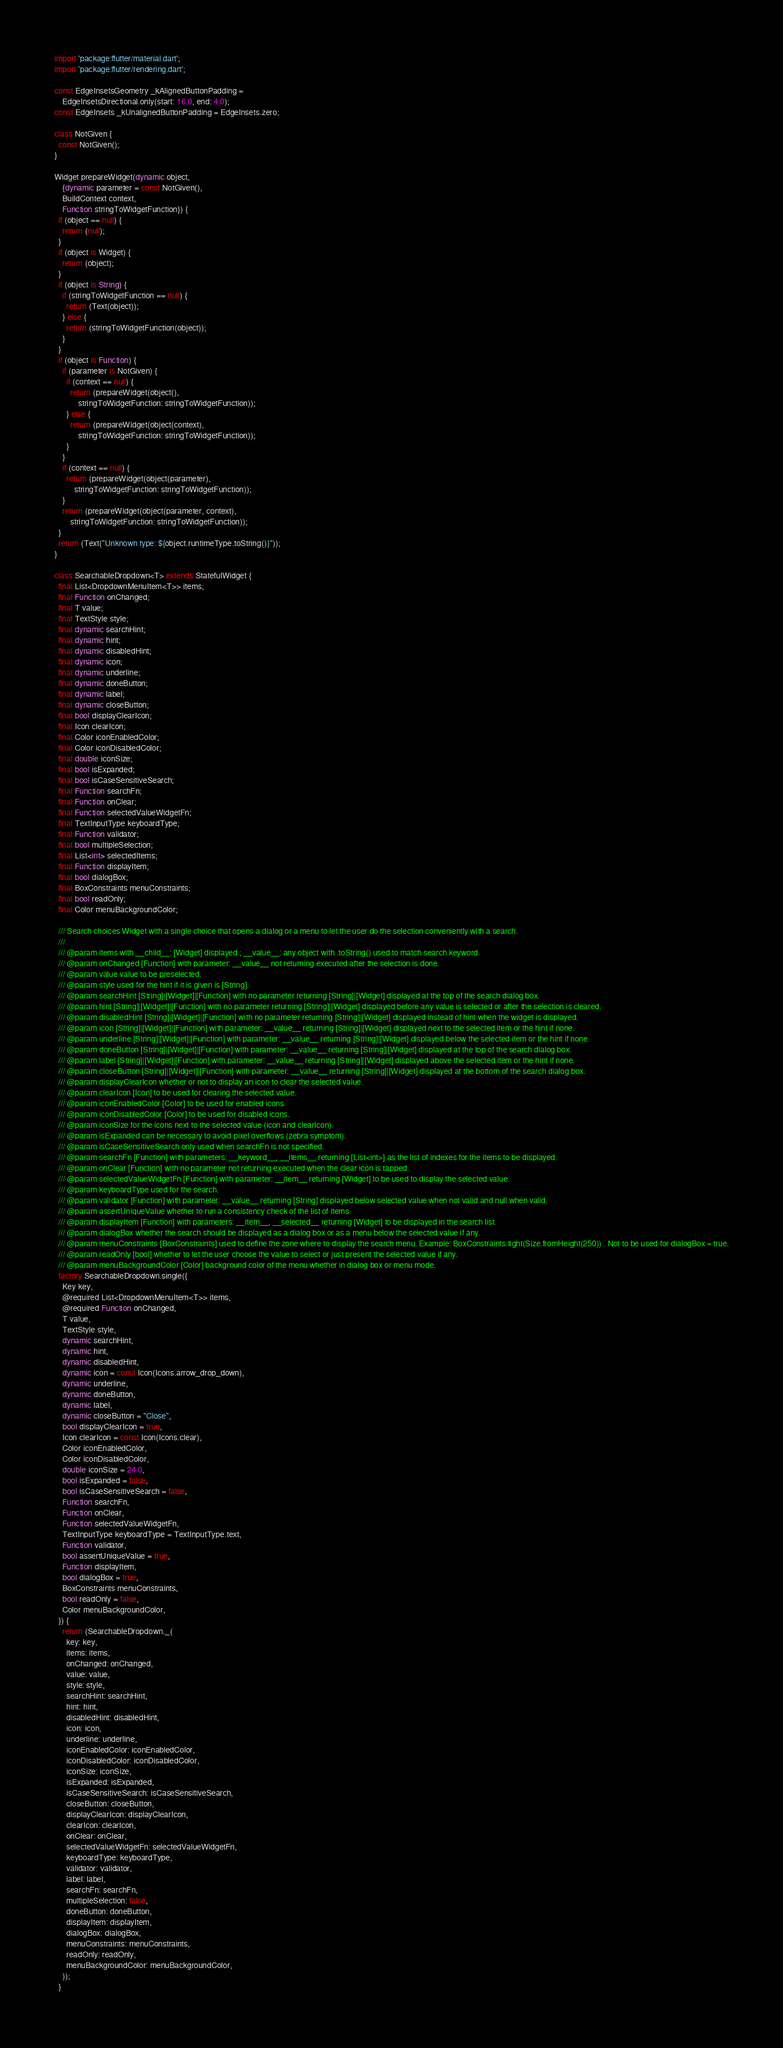<code> <loc_0><loc_0><loc_500><loc_500><_Dart_>import 'package:flutter/material.dart';
import 'package:flutter/rendering.dart';

const EdgeInsetsGeometry _kAlignedButtonPadding =
    EdgeInsetsDirectional.only(start: 16.0, end: 4.0);
const EdgeInsets _kUnalignedButtonPadding = EdgeInsets.zero;

class NotGiven {
  const NotGiven();
}

Widget prepareWidget(dynamic object,
    {dynamic parameter = const NotGiven(),
    BuildContext context,
    Function stringToWidgetFunction}) {
  if (object == null) {
    return (null);
  }
  if (object is Widget) {
    return (object);
  }
  if (object is String) {
    if (stringToWidgetFunction == null) {
      return (Text(object));
    } else {
      return (stringToWidgetFunction(object));
    }
  }
  if (object is Function) {
    if (parameter is NotGiven) {
      if (context == null) {
        return (prepareWidget(object(),
            stringToWidgetFunction: stringToWidgetFunction));
      } else {
        return (prepareWidget(object(context),
            stringToWidgetFunction: stringToWidgetFunction));
      }
    }
    if (context == null) {
      return (prepareWidget(object(parameter),
          stringToWidgetFunction: stringToWidgetFunction));
    }
    return (prepareWidget(object(parameter, context),
        stringToWidgetFunction: stringToWidgetFunction));
  }
  return (Text("Unknown type: ${object.runtimeType.toString()}"));
}

class SearchableDropdown<T> extends StatefulWidget {
  final List<DropdownMenuItem<T>> items;
  final Function onChanged;
  final T value;
  final TextStyle style;
  final dynamic searchHint;
  final dynamic hint;
  final dynamic disabledHint;
  final dynamic icon;
  final dynamic underline;
  final dynamic doneButton;
  final dynamic label;
  final dynamic closeButton;
  final bool displayClearIcon;
  final Icon clearIcon;
  final Color iconEnabledColor;
  final Color iconDisabledColor;
  final double iconSize;
  final bool isExpanded;
  final bool isCaseSensitiveSearch;
  final Function searchFn;
  final Function onClear;
  final Function selectedValueWidgetFn;
  final TextInputType keyboardType;
  final Function validator;
  final bool multipleSelection;
  final List<int> selectedItems;
  final Function displayItem;
  final bool dialogBox;
  final BoxConstraints menuConstraints;
  final bool readOnly;
  final Color menuBackgroundColor;

  /// Search choices Widget with a single choice that opens a dialog or a menu to let the user do the selection conveniently with a search.
  ///
  /// @param items with __child__: [Widget] displayed ; __value__: any object with .toString() used to match search keyword.
  /// @param onChanged [Function] with parameter: __value__ not returning executed after the selection is done.
  /// @param value value to be preselected.
  /// @param style used for the hint if it is given is [String].
  /// @param searchHint [String]|[Widget]|[Function] with no parameter returning [String]|[Widget] displayed at the top of the search dialog box.
  /// @param hint [String]|[Widget]|[Function] with no parameter returning [String]|[Widget] displayed before any value is selected or after the selection is cleared.
  /// @param disabledHint [String]|[Widget]|[Function] with no parameter returning [String]|[Widget] displayed instead of hint when the widget is displayed.
  /// @param icon [String]|[Widget]|[Function] with parameter: __value__ returning [String]|[Widget] displayed next to the selected item or the hint if none.
  /// @param underline [String]|[Widget]|[Function] with parameter: __value__ returning [String]|[Widget] displayed below the selected item or the hint if none.
  /// @param doneButton [String]|[Widget]|[Function] with parameter: __value__ returning [String]|[Widget] displayed at the top of the search dialog box.
  /// @param label [String]|[Widget]|[Function] with parameter: __value__ returning [String]|[Widget] displayed above the selected item or the hint if none.
  /// @param closeButton [String]|[Widget]|[Function] with parameter: __value__ returning [String]|[Widget] displayed at the bottom of the search dialog box.
  /// @param displayClearIcon whether or not to display an icon to clear the selected value.
  /// @param clearIcon [Icon] to be used for clearing the selected value.
  /// @param iconEnabledColor [Color] to be used for enabled icons.
  /// @param iconDisabledColor [Color] to be used for disabled icons.
  /// @param iconSize for the icons next to the selected value (icon and clearIcon).
  /// @param isExpanded can be necessary to avoid pixel overflows (zebra symptom).
  /// @param isCaseSensitiveSearch only used when searchFn is not specified.
  /// @param searchFn [Function] with parameters: __keyword__, __items__ returning [List<int>] as the list of indexes for the items to be displayed.
  /// @param onClear [Function] with no parameter not returning executed when the clear icon is tapped.
  /// @param selectedValueWidgetFn [Function] with parameter: __item__ returning [Widget] to be used to display the selected value.
  /// @param keyboardType used for the search.
  /// @param validator [Function] with parameter: __value__ returning [String] displayed below selected value when not valid and null when valid.
  /// @param assertUniqueValue whether to run a consistency check of the list of items.
  /// @param displayItem [Function] with parameters: __item__, __selected__ returning [Widget] to be displayed in the search list.
  /// @param dialogBox whether the search should be displayed as a dialog box or as a menu below the selected value if any.
  /// @param menuConstraints [BoxConstraints] used to define the zone where to display the search menu. Example: BoxConstraints.tight(Size.fromHeight(250)) . Not to be used for dialogBox = true.
  /// @param readOnly [bool] whether to let the user choose the value to select or just present the selected value if any.
  /// @param menuBackgroundColor [Color] background color of the menu whether in dialog box or menu mode.
  factory SearchableDropdown.single({
    Key key,
    @required List<DropdownMenuItem<T>> items,
    @required Function onChanged,
    T value,
    TextStyle style,
    dynamic searchHint,
    dynamic hint,
    dynamic disabledHint,
    dynamic icon = const Icon(Icons.arrow_drop_down),
    dynamic underline,
    dynamic doneButton,
    dynamic label,
    dynamic closeButton = "Close",
    bool displayClearIcon = true,
    Icon clearIcon = const Icon(Icons.clear),
    Color iconEnabledColor,
    Color iconDisabledColor,
    double iconSize = 24.0,
    bool isExpanded = false,
    bool isCaseSensitiveSearch = false,
    Function searchFn,
    Function onClear,
    Function selectedValueWidgetFn,
    TextInputType keyboardType = TextInputType.text,
    Function validator,
    bool assertUniqueValue = true,
    Function displayItem,
    bool dialogBox = true,
    BoxConstraints menuConstraints,
    bool readOnly = false,
    Color menuBackgroundColor,
  }) {
    return (SearchableDropdown._(
      key: key,
      items: items,
      onChanged: onChanged,
      value: value,
      style: style,
      searchHint: searchHint,
      hint: hint,
      disabledHint: disabledHint,
      icon: icon,
      underline: underline,
      iconEnabledColor: iconEnabledColor,
      iconDisabledColor: iconDisabledColor,
      iconSize: iconSize,
      isExpanded: isExpanded,
      isCaseSensitiveSearch: isCaseSensitiveSearch,
      closeButton: closeButton,
      displayClearIcon: displayClearIcon,
      clearIcon: clearIcon,
      onClear: onClear,
      selectedValueWidgetFn: selectedValueWidgetFn,
      keyboardType: keyboardType,
      validator: validator,
      label: label,
      searchFn: searchFn,
      multipleSelection: false,
      doneButton: doneButton,
      displayItem: displayItem,
      dialogBox: dialogBox,
      menuConstraints: menuConstraints,
      readOnly: readOnly,
      menuBackgroundColor: menuBackgroundColor,
    ));
  }
</code> 